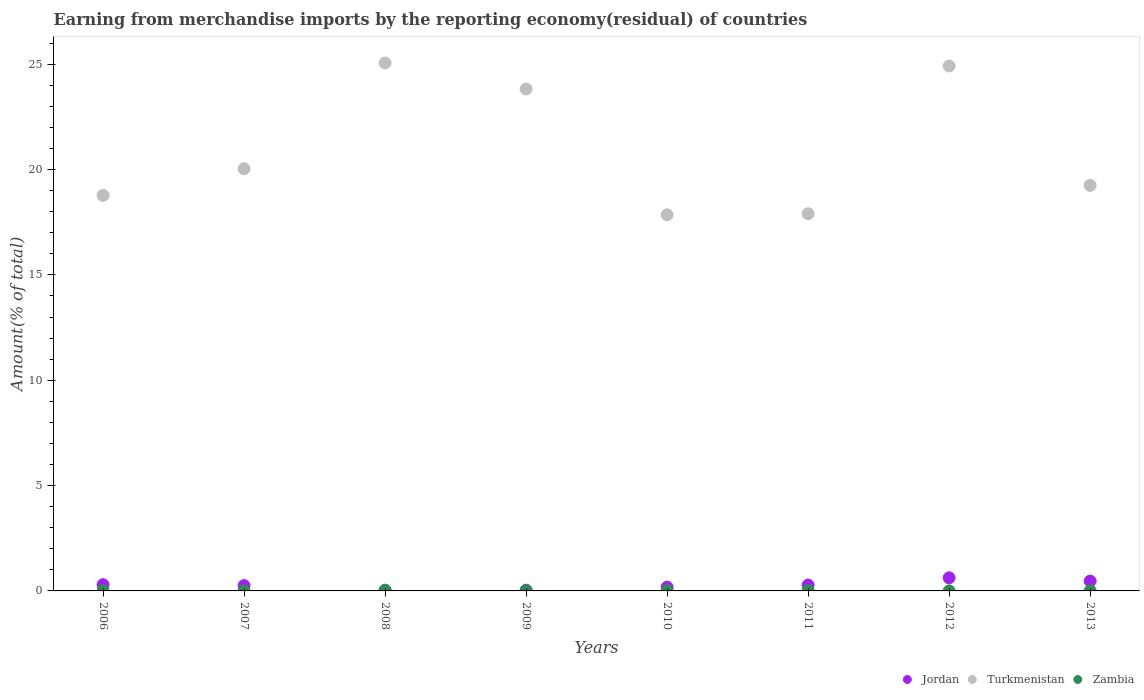How many different coloured dotlines are there?
Provide a succinct answer. 3. Is the number of dotlines equal to the number of legend labels?
Your response must be concise. Yes. What is the percentage of amount earned from merchandise imports in Turkmenistan in 2011?
Your answer should be compact. 17.9. Across all years, what is the maximum percentage of amount earned from merchandise imports in Zambia?
Your response must be concise. 0.03. Across all years, what is the minimum percentage of amount earned from merchandise imports in Jordan?
Your response must be concise. 0.03. In which year was the percentage of amount earned from merchandise imports in Turkmenistan maximum?
Provide a succinct answer. 2008. In which year was the percentage of amount earned from merchandise imports in Jordan minimum?
Offer a terse response. 2008. What is the total percentage of amount earned from merchandise imports in Turkmenistan in the graph?
Keep it short and to the point. 167.63. What is the difference between the percentage of amount earned from merchandise imports in Zambia in 2006 and that in 2009?
Provide a short and direct response. 0.01. What is the difference between the percentage of amount earned from merchandise imports in Turkmenistan in 2010 and the percentage of amount earned from merchandise imports in Jordan in 2007?
Offer a terse response. 17.6. What is the average percentage of amount earned from merchandise imports in Zambia per year?
Keep it short and to the point. 0.01. In the year 2012, what is the difference between the percentage of amount earned from merchandise imports in Turkmenistan and percentage of amount earned from merchandise imports in Jordan?
Make the answer very short. 24.3. In how many years, is the percentage of amount earned from merchandise imports in Jordan greater than 9 %?
Offer a terse response. 0. What is the ratio of the percentage of amount earned from merchandise imports in Turkmenistan in 2007 to that in 2008?
Provide a short and direct response. 0.8. Is the percentage of amount earned from merchandise imports in Zambia in 2008 less than that in 2010?
Your answer should be very brief. No. What is the difference between the highest and the second highest percentage of amount earned from merchandise imports in Zambia?
Provide a short and direct response. 0.01. What is the difference between the highest and the lowest percentage of amount earned from merchandise imports in Zambia?
Provide a short and direct response. 0.03. Is the sum of the percentage of amount earned from merchandise imports in Zambia in 2009 and 2011 greater than the maximum percentage of amount earned from merchandise imports in Turkmenistan across all years?
Provide a short and direct response. No. Is it the case that in every year, the sum of the percentage of amount earned from merchandise imports in Jordan and percentage of amount earned from merchandise imports in Zambia  is greater than the percentage of amount earned from merchandise imports in Turkmenistan?
Offer a very short reply. No. Is the percentage of amount earned from merchandise imports in Turkmenistan strictly greater than the percentage of amount earned from merchandise imports in Jordan over the years?
Keep it short and to the point. Yes. Is the percentage of amount earned from merchandise imports in Jordan strictly less than the percentage of amount earned from merchandise imports in Zambia over the years?
Your answer should be very brief. No. How many years are there in the graph?
Your answer should be compact. 8. What is the difference between two consecutive major ticks on the Y-axis?
Make the answer very short. 5. Are the values on the major ticks of Y-axis written in scientific E-notation?
Your answer should be compact. No. Does the graph contain any zero values?
Give a very brief answer. No. Where does the legend appear in the graph?
Keep it short and to the point. Bottom right. How many legend labels are there?
Keep it short and to the point. 3. How are the legend labels stacked?
Your response must be concise. Horizontal. What is the title of the graph?
Provide a succinct answer. Earning from merchandise imports by the reporting economy(residual) of countries. Does "Poland" appear as one of the legend labels in the graph?
Your answer should be very brief. No. What is the label or title of the Y-axis?
Provide a succinct answer. Amount(% of total). What is the Amount(% of total) in Jordan in 2006?
Your answer should be very brief. 0.3. What is the Amount(% of total) of Turkmenistan in 2006?
Provide a succinct answer. 18.78. What is the Amount(% of total) in Zambia in 2006?
Your response must be concise. 0.01. What is the Amount(% of total) of Jordan in 2007?
Ensure brevity in your answer.  0.25. What is the Amount(% of total) in Turkmenistan in 2007?
Your answer should be compact. 20.04. What is the Amount(% of total) in Zambia in 2007?
Give a very brief answer. 0. What is the Amount(% of total) of Jordan in 2008?
Give a very brief answer. 0.03. What is the Amount(% of total) in Turkmenistan in 2008?
Offer a very short reply. 25.06. What is the Amount(% of total) in Zambia in 2008?
Make the answer very short. 0.03. What is the Amount(% of total) in Jordan in 2009?
Ensure brevity in your answer.  0.04. What is the Amount(% of total) in Turkmenistan in 2009?
Make the answer very short. 23.83. What is the Amount(% of total) of Zambia in 2009?
Offer a very short reply. 0.01. What is the Amount(% of total) in Jordan in 2010?
Your answer should be compact. 0.18. What is the Amount(% of total) of Turkmenistan in 2010?
Ensure brevity in your answer.  17.85. What is the Amount(% of total) of Zambia in 2010?
Make the answer very short. 0.01. What is the Amount(% of total) of Jordan in 2011?
Offer a terse response. 0.28. What is the Amount(% of total) in Turkmenistan in 2011?
Keep it short and to the point. 17.9. What is the Amount(% of total) of Zambia in 2011?
Ensure brevity in your answer.  0.02. What is the Amount(% of total) of Jordan in 2012?
Offer a terse response. 0.62. What is the Amount(% of total) in Turkmenistan in 2012?
Offer a very short reply. 24.92. What is the Amount(% of total) of Zambia in 2012?
Offer a very short reply. 0. What is the Amount(% of total) of Jordan in 2013?
Ensure brevity in your answer.  0.47. What is the Amount(% of total) of Turkmenistan in 2013?
Make the answer very short. 19.25. What is the Amount(% of total) in Zambia in 2013?
Provide a short and direct response. 0.01. Across all years, what is the maximum Amount(% of total) in Jordan?
Your response must be concise. 0.62. Across all years, what is the maximum Amount(% of total) of Turkmenistan?
Keep it short and to the point. 25.06. Across all years, what is the maximum Amount(% of total) of Zambia?
Keep it short and to the point. 0.03. Across all years, what is the minimum Amount(% of total) of Jordan?
Provide a succinct answer. 0.03. Across all years, what is the minimum Amount(% of total) in Turkmenistan?
Your answer should be very brief. 17.85. Across all years, what is the minimum Amount(% of total) in Zambia?
Offer a very short reply. 0. What is the total Amount(% of total) of Jordan in the graph?
Keep it short and to the point. 2.17. What is the total Amount(% of total) of Turkmenistan in the graph?
Give a very brief answer. 167.63. What is the total Amount(% of total) of Zambia in the graph?
Offer a very short reply. 0.1. What is the difference between the Amount(% of total) of Jordan in 2006 and that in 2007?
Provide a succinct answer. 0.04. What is the difference between the Amount(% of total) in Turkmenistan in 2006 and that in 2007?
Your answer should be compact. -1.26. What is the difference between the Amount(% of total) of Zambia in 2006 and that in 2007?
Keep it short and to the point. 0.01. What is the difference between the Amount(% of total) of Jordan in 2006 and that in 2008?
Offer a terse response. 0.26. What is the difference between the Amount(% of total) in Turkmenistan in 2006 and that in 2008?
Your answer should be very brief. -6.28. What is the difference between the Amount(% of total) of Zambia in 2006 and that in 2008?
Give a very brief answer. -0.02. What is the difference between the Amount(% of total) of Jordan in 2006 and that in 2009?
Keep it short and to the point. 0.26. What is the difference between the Amount(% of total) of Turkmenistan in 2006 and that in 2009?
Give a very brief answer. -5.05. What is the difference between the Amount(% of total) in Zambia in 2006 and that in 2009?
Offer a very short reply. 0.01. What is the difference between the Amount(% of total) of Jordan in 2006 and that in 2010?
Offer a terse response. 0.12. What is the difference between the Amount(% of total) of Turkmenistan in 2006 and that in 2010?
Provide a short and direct response. 0.92. What is the difference between the Amount(% of total) in Zambia in 2006 and that in 2010?
Keep it short and to the point. 0. What is the difference between the Amount(% of total) in Jordan in 2006 and that in 2011?
Your answer should be compact. 0.01. What is the difference between the Amount(% of total) of Turkmenistan in 2006 and that in 2011?
Give a very brief answer. 0.87. What is the difference between the Amount(% of total) in Zambia in 2006 and that in 2011?
Your answer should be compact. -0.01. What is the difference between the Amount(% of total) in Jordan in 2006 and that in 2012?
Offer a very short reply. -0.33. What is the difference between the Amount(% of total) in Turkmenistan in 2006 and that in 2012?
Keep it short and to the point. -6.14. What is the difference between the Amount(% of total) of Zambia in 2006 and that in 2012?
Your answer should be compact. 0.01. What is the difference between the Amount(% of total) in Jordan in 2006 and that in 2013?
Keep it short and to the point. -0.17. What is the difference between the Amount(% of total) of Turkmenistan in 2006 and that in 2013?
Make the answer very short. -0.47. What is the difference between the Amount(% of total) in Zambia in 2006 and that in 2013?
Your answer should be very brief. 0. What is the difference between the Amount(% of total) in Jordan in 2007 and that in 2008?
Make the answer very short. 0.22. What is the difference between the Amount(% of total) in Turkmenistan in 2007 and that in 2008?
Your response must be concise. -5.02. What is the difference between the Amount(% of total) in Zambia in 2007 and that in 2008?
Keep it short and to the point. -0.02. What is the difference between the Amount(% of total) in Jordan in 2007 and that in 2009?
Your response must be concise. 0.22. What is the difference between the Amount(% of total) of Turkmenistan in 2007 and that in 2009?
Keep it short and to the point. -3.79. What is the difference between the Amount(% of total) in Zambia in 2007 and that in 2009?
Offer a very short reply. -0. What is the difference between the Amount(% of total) in Jordan in 2007 and that in 2010?
Make the answer very short. 0.07. What is the difference between the Amount(% of total) in Turkmenistan in 2007 and that in 2010?
Your answer should be very brief. 2.19. What is the difference between the Amount(% of total) of Zambia in 2007 and that in 2010?
Offer a terse response. -0.01. What is the difference between the Amount(% of total) of Jordan in 2007 and that in 2011?
Provide a succinct answer. -0.03. What is the difference between the Amount(% of total) in Turkmenistan in 2007 and that in 2011?
Keep it short and to the point. 2.14. What is the difference between the Amount(% of total) in Zambia in 2007 and that in 2011?
Your answer should be compact. -0.02. What is the difference between the Amount(% of total) of Jordan in 2007 and that in 2012?
Your answer should be compact. -0.37. What is the difference between the Amount(% of total) in Turkmenistan in 2007 and that in 2012?
Your answer should be compact. -4.88. What is the difference between the Amount(% of total) in Zambia in 2007 and that in 2012?
Provide a short and direct response. 0. What is the difference between the Amount(% of total) in Jordan in 2007 and that in 2013?
Your response must be concise. -0.22. What is the difference between the Amount(% of total) of Turkmenistan in 2007 and that in 2013?
Give a very brief answer. 0.79. What is the difference between the Amount(% of total) of Zambia in 2007 and that in 2013?
Offer a terse response. -0.01. What is the difference between the Amount(% of total) in Jordan in 2008 and that in 2009?
Provide a succinct answer. -0. What is the difference between the Amount(% of total) of Turkmenistan in 2008 and that in 2009?
Provide a succinct answer. 1.23. What is the difference between the Amount(% of total) of Zambia in 2008 and that in 2009?
Your answer should be compact. 0.02. What is the difference between the Amount(% of total) of Jordan in 2008 and that in 2010?
Provide a succinct answer. -0.15. What is the difference between the Amount(% of total) of Turkmenistan in 2008 and that in 2010?
Provide a short and direct response. 7.21. What is the difference between the Amount(% of total) of Zambia in 2008 and that in 2010?
Keep it short and to the point. 0.02. What is the difference between the Amount(% of total) of Jordan in 2008 and that in 2011?
Your response must be concise. -0.25. What is the difference between the Amount(% of total) of Turkmenistan in 2008 and that in 2011?
Your answer should be very brief. 7.16. What is the difference between the Amount(% of total) of Zambia in 2008 and that in 2011?
Your response must be concise. 0.01. What is the difference between the Amount(% of total) of Jordan in 2008 and that in 2012?
Your response must be concise. -0.59. What is the difference between the Amount(% of total) of Turkmenistan in 2008 and that in 2012?
Provide a succinct answer. 0.14. What is the difference between the Amount(% of total) of Zambia in 2008 and that in 2012?
Provide a succinct answer. 0.03. What is the difference between the Amount(% of total) of Jordan in 2008 and that in 2013?
Offer a very short reply. -0.44. What is the difference between the Amount(% of total) in Turkmenistan in 2008 and that in 2013?
Your response must be concise. 5.81. What is the difference between the Amount(% of total) in Zambia in 2008 and that in 2013?
Make the answer very short. 0.02. What is the difference between the Amount(% of total) of Jordan in 2009 and that in 2010?
Give a very brief answer. -0.15. What is the difference between the Amount(% of total) in Turkmenistan in 2009 and that in 2010?
Make the answer very short. 5.97. What is the difference between the Amount(% of total) of Zambia in 2009 and that in 2010?
Give a very brief answer. -0. What is the difference between the Amount(% of total) in Jordan in 2009 and that in 2011?
Ensure brevity in your answer.  -0.25. What is the difference between the Amount(% of total) in Turkmenistan in 2009 and that in 2011?
Provide a succinct answer. 5.92. What is the difference between the Amount(% of total) in Zambia in 2009 and that in 2011?
Offer a terse response. -0.02. What is the difference between the Amount(% of total) in Jordan in 2009 and that in 2012?
Ensure brevity in your answer.  -0.59. What is the difference between the Amount(% of total) of Turkmenistan in 2009 and that in 2012?
Keep it short and to the point. -1.09. What is the difference between the Amount(% of total) in Zambia in 2009 and that in 2012?
Offer a very short reply. 0. What is the difference between the Amount(% of total) of Jordan in 2009 and that in 2013?
Offer a terse response. -0.43. What is the difference between the Amount(% of total) in Turkmenistan in 2009 and that in 2013?
Provide a short and direct response. 4.58. What is the difference between the Amount(% of total) in Zambia in 2009 and that in 2013?
Provide a succinct answer. -0. What is the difference between the Amount(% of total) of Jordan in 2010 and that in 2011?
Provide a succinct answer. -0.1. What is the difference between the Amount(% of total) in Turkmenistan in 2010 and that in 2011?
Your response must be concise. -0.05. What is the difference between the Amount(% of total) of Zambia in 2010 and that in 2011?
Give a very brief answer. -0.01. What is the difference between the Amount(% of total) of Jordan in 2010 and that in 2012?
Your answer should be compact. -0.44. What is the difference between the Amount(% of total) in Turkmenistan in 2010 and that in 2012?
Give a very brief answer. -7.07. What is the difference between the Amount(% of total) of Zambia in 2010 and that in 2012?
Offer a terse response. 0.01. What is the difference between the Amount(% of total) of Jordan in 2010 and that in 2013?
Give a very brief answer. -0.29. What is the difference between the Amount(% of total) in Turkmenistan in 2010 and that in 2013?
Provide a succinct answer. -1.4. What is the difference between the Amount(% of total) of Zambia in 2010 and that in 2013?
Offer a very short reply. -0. What is the difference between the Amount(% of total) of Jordan in 2011 and that in 2012?
Ensure brevity in your answer.  -0.34. What is the difference between the Amount(% of total) in Turkmenistan in 2011 and that in 2012?
Keep it short and to the point. -7.02. What is the difference between the Amount(% of total) of Zambia in 2011 and that in 2012?
Give a very brief answer. 0.02. What is the difference between the Amount(% of total) of Jordan in 2011 and that in 2013?
Provide a succinct answer. -0.19. What is the difference between the Amount(% of total) of Turkmenistan in 2011 and that in 2013?
Offer a terse response. -1.35. What is the difference between the Amount(% of total) of Zambia in 2011 and that in 2013?
Offer a very short reply. 0.01. What is the difference between the Amount(% of total) in Jordan in 2012 and that in 2013?
Give a very brief answer. 0.15. What is the difference between the Amount(% of total) in Turkmenistan in 2012 and that in 2013?
Keep it short and to the point. 5.67. What is the difference between the Amount(% of total) in Zambia in 2012 and that in 2013?
Provide a succinct answer. -0.01. What is the difference between the Amount(% of total) in Jordan in 2006 and the Amount(% of total) in Turkmenistan in 2007?
Provide a short and direct response. -19.74. What is the difference between the Amount(% of total) of Jordan in 2006 and the Amount(% of total) of Zambia in 2007?
Make the answer very short. 0.29. What is the difference between the Amount(% of total) of Turkmenistan in 2006 and the Amount(% of total) of Zambia in 2007?
Offer a very short reply. 18.77. What is the difference between the Amount(% of total) in Jordan in 2006 and the Amount(% of total) in Turkmenistan in 2008?
Give a very brief answer. -24.76. What is the difference between the Amount(% of total) of Jordan in 2006 and the Amount(% of total) of Zambia in 2008?
Keep it short and to the point. 0.27. What is the difference between the Amount(% of total) of Turkmenistan in 2006 and the Amount(% of total) of Zambia in 2008?
Offer a very short reply. 18.75. What is the difference between the Amount(% of total) of Jordan in 2006 and the Amount(% of total) of Turkmenistan in 2009?
Offer a terse response. -23.53. What is the difference between the Amount(% of total) of Jordan in 2006 and the Amount(% of total) of Zambia in 2009?
Provide a succinct answer. 0.29. What is the difference between the Amount(% of total) of Turkmenistan in 2006 and the Amount(% of total) of Zambia in 2009?
Offer a very short reply. 18.77. What is the difference between the Amount(% of total) of Jordan in 2006 and the Amount(% of total) of Turkmenistan in 2010?
Your answer should be compact. -17.56. What is the difference between the Amount(% of total) in Jordan in 2006 and the Amount(% of total) in Zambia in 2010?
Ensure brevity in your answer.  0.29. What is the difference between the Amount(% of total) in Turkmenistan in 2006 and the Amount(% of total) in Zambia in 2010?
Offer a very short reply. 18.77. What is the difference between the Amount(% of total) in Jordan in 2006 and the Amount(% of total) in Turkmenistan in 2011?
Offer a very short reply. -17.61. What is the difference between the Amount(% of total) of Jordan in 2006 and the Amount(% of total) of Zambia in 2011?
Give a very brief answer. 0.27. What is the difference between the Amount(% of total) of Turkmenistan in 2006 and the Amount(% of total) of Zambia in 2011?
Keep it short and to the point. 18.75. What is the difference between the Amount(% of total) in Jordan in 2006 and the Amount(% of total) in Turkmenistan in 2012?
Ensure brevity in your answer.  -24.62. What is the difference between the Amount(% of total) of Jordan in 2006 and the Amount(% of total) of Zambia in 2012?
Keep it short and to the point. 0.29. What is the difference between the Amount(% of total) in Turkmenistan in 2006 and the Amount(% of total) in Zambia in 2012?
Your answer should be very brief. 18.77. What is the difference between the Amount(% of total) of Jordan in 2006 and the Amount(% of total) of Turkmenistan in 2013?
Provide a short and direct response. -18.95. What is the difference between the Amount(% of total) of Jordan in 2006 and the Amount(% of total) of Zambia in 2013?
Offer a terse response. 0.28. What is the difference between the Amount(% of total) of Turkmenistan in 2006 and the Amount(% of total) of Zambia in 2013?
Your answer should be compact. 18.77. What is the difference between the Amount(% of total) in Jordan in 2007 and the Amount(% of total) in Turkmenistan in 2008?
Make the answer very short. -24.81. What is the difference between the Amount(% of total) in Jordan in 2007 and the Amount(% of total) in Zambia in 2008?
Provide a short and direct response. 0.22. What is the difference between the Amount(% of total) in Turkmenistan in 2007 and the Amount(% of total) in Zambia in 2008?
Offer a very short reply. 20.01. What is the difference between the Amount(% of total) of Jordan in 2007 and the Amount(% of total) of Turkmenistan in 2009?
Make the answer very short. -23.58. What is the difference between the Amount(% of total) in Jordan in 2007 and the Amount(% of total) in Zambia in 2009?
Keep it short and to the point. 0.24. What is the difference between the Amount(% of total) in Turkmenistan in 2007 and the Amount(% of total) in Zambia in 2009?
Your answer should be very brief. 20.03. What is the difference between the Amount(% of total) in Jordan in 2007 and the Amount(% of total) in Turkmenistan in 2010?
Offer a terse response. -17.6. What is the difference between the Amount(% of total) in Jordan in 2007 and the Amount(% of total) in Zambia in 2010?
Provide a succinct answer. 0.24. What is the difference between the Amount(% of total) in Turkmenistan in 2007 and the Amount(% of total) in Zambia in 2010?
Provide a succinct answer. 20.03. What is the difference between the Amount(% of total) in Jordan in 2007 and the Amount(% of total) in Turkmenistan in 2011?
Make the answer very short. -17.65. What is the difference between the Amount(% of total) of Jordan in 2007 and the Amount(% of total) of Zambia in 2011?
Keep it short and to the point. 0.23. What is the difference between the Amount(% of total) of Turkmenistan in 2007 and the Amount(% of total) of Zambia in 2011?
Your response must be concise. 20.02. What is the difference between the Amount(% of total) of Jordan in 2007 and the Amount(% of total) of Turkmenistan in 2012?
Provide a short and direct response. -24.67. What is the difference between the Amount(% of total) in Jordan in 2007 and the Amount(% of total) in Zambia in 2012?
Your answer should be compact. 0.25. What is the difference between the Amount(% of total) of Turkmenistan in 2007 and the Amount(% of total) of Zambia in 2012?
Make the answer very short. 20.04. What is the difference between the Amount(% of total) of Jordan in 2007 and the Amount(% of total) of Turkmenistan in 2013?
Your answer should be compact. -19. What is the difference between the Amount(% of total) of Jordan in 2007 and the Amount(% of total) of Zambia in 2013?
Ensure brevity in your answer.  0.24. What is the difference between the Amount(% of total) in Turkmenistan in 2007 and the Amount(% of total) in Zambia in 2013?
Keep it short and to the point. 20.03. What is the difference between the Amount(% of total) in Jordan in 2008 and the Amount(% of total) in Turkmenistan in 2009?
Your answer should be very brief. -23.8. What is the difference between the Amount(% of total) of Jordan in 2008 and the Amount(% of total) of Zambia in 2009?
Make the answer very short. 0.02. What is the difference between the Amount(% of total) of Turkmenistan in 2008 and the Amount(% of total) of Zambia in 2009?
Provide a succinct answer. 25.05. What is the difference between the Amount(% of total) in Jordan in 2008 and the Amount(% of total) in Turkmenistan in 2010?
Your response must be concise. -17.82. What is the difference between the Amount(% of total) in Jordan in 2008 and the Amount(% of total) in Zambia in 2010?
Ensure brevity in your answer.  0.02. What is the difference between the Amount(% of total) in Turkmenistan in 2008 and the Amount(% of total) in Zambia in 2010?
Provide a succinct answer. 25.05. What is the difference between the Amount(% of total) of Jordan in 2008 and the Amount(% of total) of Turkmenistan in 2011?
Provide a succinct answer. -17.87. What is the difference between the Amount(% of total) of Jordan in 2008 and the Amount(% of total) of Zambia in 2011?
Your response must be concise. 0.01. What is the difference between the Amount(% of total) of Turkmenistan in 2008 and the Amount(% of total) of Zambia in 2011?
Your answer should be compact. 25.04. What is the difference between the Amount(% of total) of Jordan in 2008 and the Amount(% of total) of Turkmenistan in 2012?
Make the answer very short. -24.89. What is the difference between the Amount(% of total) in Jordan in 2008 and the Amount(% of total) in Zambia in 2012?
Ensure brevity in your answer.  0.03. What is the difference between the Amount(% of total) of Turkmenistan in 2008 and the Amount(% of total) of Zambia in 2012?
Provide a short and direct response. 25.06. What is the difference between the Amount(% of total) of Jordan in 2008 and the Amount(% of total) of Turkmenistan in 2013?
Provide a succinct answer. -19.22. What is the difference between the Amount(% of total) in Jordan in 2008 and the Amount(% of total) in Zambia in 2013?
Provide a succinct answer. 0.02. What is the difference between the Amount(% of total) of Turkmenistan in 2008 and the Amount(% of total) of Zambia in 2013?
Give a very brief answer. 25.05. What is the difference between the Amount(% of total) in Jordan in 2009 and the Amount(% of total) in Turkmenistan in 2010?
Ensure brevity in your answer.  -17.82. What is the difference between the Amount(% of total) of Jordan in 2009 and the Amount(% of total) of Zambia in 2010?
Keep it short and to the point. 0.03. What is the difference between the Amount(% of total) of Turkmenistan in 2009 and the Amount(% of total) of Zambia in 2010?
Make the answer very short. 23.82. What is the difference between the Amount(% of total) in Jordan in 2009 and the Amount(% of total) in Turkmenistan in 2011?
Provide a short and direct response. -17.87. What is the difference between the Amount(% of total) in Jordan in 2009 and the Amount(% of total) in Zambia in 2011?
Your response must be concise. 0.01. What is the difference between the Amount(% of total) of Turkmenistan in 2009 and the Amount(% of total) of Zambia in 2011?
Keep it short and to the point. 23.8. What is the difference between the Amount(% of total) of Jordan in 2009 and the Amount(% of total) of Turkmenistan in 2012?
Your answer should be very brief. -24.89. What is the difference between the Amount(% of total) of Jordan in 2009 and the Amount(% of total) of Zambia in 2012?
Ensure brevity in your answer.  0.03. What is the difference between the Amount(% of total) in Turkmenistan in 2009 and the Amount(% of total) in Zambia in 2012?
Ensure brevity in your answer.  23.82. What is the difference between the Amount(% of total) in Jordan in 2009 and the Amount(% of total) in Turkmenistan in 2013?
Ensure brevity in your answer.  -19.22. What is the difference between the Amount(% of total) of Jordan in 2009 and the Amount(% of total) of Zambia in 2013?
Ensure brevity in your answer.  0.02. What is the difference between the Amount(% of total) in Turkmenistan in 2009 and the Amount(% of total) in Zambia in 2013?
Keep it short and to the point. 23.82. What is the difference between the Amount(% of total) in Jordan in 2010 and the Amount(% of total) in Turkmenistan in 2011?
Make the answer very short. -17.72. What is the difference between the Amount(% of total) in Jordan in 2010 and the Amount(% of total) in Zambia in 2011?
Provide a short and direct response. 0.16. What is the difference between the Amount(% of total) in Turkmenistan in 2010 and the Amount(% of total) in Zambia in 2011?
Provide a short and direct response. 17.83. What is the difference between the Amount(% of total) in Jordan in 2010 and the Amount(% of total) in Turkmenistan in 2012?
Your answer should be compact. -24.74. What is the difference between the Amount(% of total) of Jordan in 2010 and the Amount(% of total) of Zambia in 2012?
Provide a succinct answer. 0.18. What is the difference between the Amount(% of total) in Turkmenistan in 2010 and the Amount(% of total) in Zambia in 2012?
Provide a short and direct response. 17.85. What is the difference between the Amount(% of total) in Jordan in 2010 and the Amount(% of total) in Turkmenistan in 2013?
Offer a terse response. -19.07. What is the difference between the Amount(% of total) of Jordan in 2010 and the Amount(% of total) of Zambia in 2013?
Offer a very short reply. 0.17. What is the difference between the Amount(% of total) in Turkmenistan in 2010 and the Amount(% of total) in Zambia in 2013?
Your answer should be very brief. 17.84. What is the difference between the Amount(% of total) of Jordan in 2011 and the Amount(% of total) of Turkmenistan in 2012?
Keep it short and to the point. -24.64. What is the difference between the Amount(% of total) in Jordan in 2011 and the Amount(% of total) in Zambia in 2012?
Your answer should be compact. 0.28. What is the difference between the Amount(% of total) of Turkmenistan in 2011 and the Amount(% of total) of Zambia in 2012?
Make the answer very short. 17.9. What is the difference between the Amount(% of total) of Jordan in 2011 and the Amount(% of total) of Turkmenistan in 2013?
Offer a very short reply. -18.97. What is the difference between the Amount(% of total) in Jordan in 2011 and the Amount(% of total) in Zambia in 2013?
Your answer should be very brief. 0.27. What is the difference between the Amount(% of total) of Turkmenistan in 2011 and the Amount(% of total) of Zambia in 2013?
Keep it short and to the point. 17.89. What is the difference between the Amount(% of total) of Jordan in 2012 and the Amount(% of total) of Turkmenistan in 2013?
Your response must be concise. -18.63. What is the difference between the Amount(% of total) of Jordan in 2012 and the Amount(% of total) of Zambia in 2013?
Provide a short and direct response. 0.61. What is the difference between the Amount(% of total) of Turkmenistan in 2012 and the Amount(% of total) of Zambia in 2013?
Offer a terse response. 24.91. What is the average Amount(% of total) in Jordan per year?
Provide a short and direct response. 0.27. What is the average Amount(% of total) in Turkmenistan per year?
Offer a very short reply. 20.95. What is the average Amount(% of total) of Zambia per year?
Your answer should be very brief. 0.01. In the year 2006, what is the difference between the Amount(% of total) of Jordan and Amount(% of total) of Turkmenistan?
Your answer should be very brief. -18.48. In the year 2006, what is the difference between the Amount(% of total) of Jordan and Amount(% of total) of Zambia?
Ensure brevity in your answer.  0.28. In the year 2006, what is the difference between the Amount(% of total) of Turkmenistan and Amount(% of total) of Zambia?
Make the answer very short. 18.76. In the year 2007, what is the difference between the Amount(% of total) of Jordan and Amount(% of total) of Turkmenistan?
Your response must be concise. -19.79. In the year 2007, what is the difference between the Amount(% of total) in Jordan and Amount(% of total) in Zambia?
Offer a very short reply. 0.25. In the year 2007, what is the difference between the Amount(% of total) of Turkmenistan and Amount(% of total) of Zambia?
Provide a succinct answer. 20.04. In the year 2008, what is the difference between the Amount(% of total) in Jordan and Amount(% of total) in Turkmenistan?
Provide a succinct answer. -25.03. In the year 2008, what is the difference between the Amount(% of total) in Jordan and Amount(% of total) in Zambia?
Give a very brief answer. 0. In the year 2008, what is the difference between the Amount(% of total) in Turkmenistan and Amount(% of total) in Zambia?
Provide a short and direct response. 25.03. In the year 2009, what is the difference between the Amount(% of total) of Jordan and Amount(% of total) of Turkmenistan?
Give a very brief answer. -23.79. In the year 2009, what is the difference between the Amount(% of total) of Jordan and Amount(% of total) of Zambia?
Your response must be concise. 0.03. In the year 2009, what is the difference between the Amount(% of total) in Turkmenistan and Amount(% of total) in Zambia?
Make the answer very short. 23.82. In the year 2010, what is the difference between the Amount(% of total) of Jordan and Amount(% of total) of Turkmenistan?
Your answer should be very brief. -17.67. In the year 2010, what is the difference between the Amount(% of total) in Jordan and Amount(% of total) in Zambia?
Offer a terse response. 0.17. In the year 2010, what is the difference between the Amount(% of total) in Turkmenistan and Amount(% of total) in Zambia?
Offer a very short reply. 17.84. In the year 2011, what is the difference between the Amount(% of total) in Jordan and Amount(% of total) in Turkmenistan?
Your answer should be compact. -17.62. In the year 2011, what is the difference between the Amount(% of total) of Jordan and Amount(% of total) of Zambia?
Give a very brief answer. 0.26. In the year 2011, what is the difference between the Amount(% of total) of Turkmenistan and Amount(% of total) of Zambia?
Your answer should be very brief. 17.88. In the year 2012, what is the difference between the Amount(% of total) in Jordan and Amount(% of total) in Turkmenistan?
Offer a terse response. -24.3. In the year 2012, what is the difference between the Amount(% of total) in Jordan and Amount(% of total) in Zambia?
Offer a terse response. 0.62. In the year 2012, what is the difference between the Amount(% of total) in Turkmenistan and Amount(% of total) in Zambia?
Ensure brevity in your answer.  24.92. In the year 2013, what is the difference between the Amount(% of total) of Jordan and Amount(% of total) of Turkmenistan?
Your response must be concise. -18.78. In the year 2013, what is the difference between the Amount(% of total) of Jordan and Amount(% of total) of Zambia?
Keep it short and to the point. 0.46. In the year 2013, what is the difference between the Amount(% of total) of Turkmenistan and Amount(% of total) of Zambia?
Offer a very short reply. 19.24. What is the ratio of the Amount(% of total) of Jordan in 2006 to that in 2007?
Your answer should be very brief. 1.18. What is the ratio of the Amount(% of total) in Turkmenistan in 2006 to that in 2007?
Provide a short and direct response. 0.94. What is the ratio of the Amount(% of total) in Zambia in 2006 to that in 2007?
Offer a terse response. 2.81. What is the ratio of the Amount(% of total) of Jordan in 2006 to that in 2008?
Provide a short and direct response. 9.4. What is the ratio of the Amount(% of total) in Turkmenistan in 2006 to that in 2008?
Your answer should be very brief. 0.75. What is the ratio of the Amount(% of total) in Zambia in 2006 to that in 2008?
Make the answer very short. 0.42. What is the ratio of the Amount(% of total) of Jordan in 2006 to that in 2009?
Make the answer very short. 8.46. What is the ratio of the Amount(% of total) in Turkmenistan in 2006 to that in 2009?
Give a very brief answer. 0.79. What is the ratio of the Amount(% of total) of Zambia in 2006 to that in 2009?
Ensure brevity in your answer.  1.77. What is the ratio of the Amount(% of total) in Jordan in 2006 to that in 2010?
Give a very brief answer. 1.64. What is the ratio of the Amount(% of total) in Turkmenistan in 2006 to that in 2010?
Your answer should be very brief. 1.05. What is the ratio of the Amount(% of total) of Zambia in 2006 to that in 2010?
Offer a very short reply. 1.32. What is the ratio of the Amount(% of total) in Jordan in 2006 to that in 2011?
Give a very brief answer. 1.05. What is the ratio of the Amount(% of total) in Turkmenistan in 2006 to that in 2011?
Your answer should be compact. 1.05. What is the ratio of the Amount(% of total) in Zambia in 2006 to that in 2011?
Ensure brevity in your answer.  0.54. What is the ratio of the Amount(% of total) in Jordan in 2006 to that in 2012?
Your answer should be very brief. 0.48. What is the ratio of the Amount(% of total) of Turkmenistan in 2006 to that in 2012?
Your answer should be compact. 0.75. What is the ratio of the Amount(% of total) of Zambia in 2006 to that in 2012?
Provide a short and direct response. 5.45. What is the ratio of the Amount(% of total) of Jordan in 2006 to that in 2013?
Ensure brevity in your answer.  0.63. What is the ratio of the Amount(% of total) in Turkmenistan in 2006 to that in 2013?
Ensure brevity in your answer.  0.98. What is the ratio of the Amount(% of total) in Zambia in 2006 to that in 2013?
Your answer should be compact. 1.08. What is the ratio of the Amount(% of total) of Jordan in 2007 to that in 2008?
Offer a very short reply. 7.99. What is the ratio of the Amount(% of total) of Turkmenistan in 2007 to that in 2008?
Offer a very short reply. 0.8. What is the ratio of the Amount(% of total) of Zambia in 2007 to that in 2008?
Offer a terse response. 0.15. What is the ratio of the Amount(% of total) of Jordan in 2007 to that in 2009?
Your answer should be very brief. 7.19. What is the ratio of the Amount(% of total) in Turkmenistan in 2007 to that in 2009?
Your answer should be very brief. 0.84. What is the ratio of the Amount(% of total) in Zambia in 2007 to that in 2009?
Provide a short and direct response. 0.63. What is the ratio of the Amount(% of total) in Jordan in 2007 to that in 2010?
Provide a short and direct response. 1.39. What is the ratio of the Amount(% of total) in Turkmenistan in 2007 to that in 2010?
Your answer should be compact. 1.12. What is the ratio of the Amount(% of total) in Zambia in 2007 to that in 2010?
Offer a very short reply. 0.47. What is the ratio of the Amount(% of total) of Jordan in 2007 to that in 2011?
Offer a terse response. 0.89. What is the ratio of the Amount(% of total) in Turkmenistan in 2007 to that in 2011?
Provide a short and direct response. 1.12. What is the ratio of the Amount(% of total) of Zambia in 2007 to that in 2011?
Provide a succinct answer. 0.19. What is the ratio of the Amount(% of total) in Jordan in 2007 to that in 2012?
Offer a terse response. 0.4. What is the ratio of the Amount(% of total) in Turkmenistan in 2007 to that in 2012?
Keep it short and to the point. 0.8. What is the ratio of the Amount(% of total) of Zambia in 2007 to that in 2012?
Provide a short and direct response. 1.94. What is the ratio of the Amount(% of total) of Jordan in 2007 to that in 2013?
Your answer should be compact. 0.54. What is the ratio of the Amount(% of total) of Turkmenistan in 2007 to that in 2013?
Your answer should be compact. 1.04. What is the ratio of the Amount(% of total) in Zambia in 2007 to that in 2013?
Offer a terse response. 0.39. What is the ratio of the Amount(% of total) in Turkmenistan in 2008 to that in 2009?
Ensure brevity in your answer.  1.05. What is the ratio of the Amount(% of total) of Zambia in 2008 to that in 2009?
Give a very brief answer. 4.18. What is the ratio of the Amount(% of total) of Jordan in 2008 to that in 2010?
Your response must be concise. 0.17. What is the ratio of the Amount(% of total) of Turkmenistan in 2008 to that in 2010?
Offer a terse response. 1.4. What is the ratio of the Amount(% of total) of Zambia in 2008 to that in 2010?
Keep it short and to the point. 3.12. What is the ratio of the Amount(% of total) of Jordan in 2008 to that in 2011?
Provide a short and direct response. 0.11. What is the ratio of the Amount(% of total) of Turkmenistan in 2008 to that in 2011?
Offer a very short reply. 1.4. What is the ratio of the Amount(% of total) in Zambia in 2008 to that in 2011?
Keep it short and to the point. 1.28. What is the ratio of the Amount(% of total) of Jordan in 2008 to that in 2012?
Your response must be concise. 0.05. What is the ratio of the Amount(% of total) of Turkmenistan in 2008 to that in 2012?
Offer a very short reply. 1.01. What is the ratio of the Amount(% of total) in Zambia in 2008 to that in 2012?
Your answer should be very brief. 12.9. What is the ratio of the Amount(% of total) of Jordan in 2008 to that in 2013?
Give a very brief answer. 0.07. What is the ratio of the Amount(% of total) of Turkmenistan in 2008 to that in 2013?
Ensure brevity in your answer.  1.3. What is the ratio of the Amount(% of total) in Zambia in 2008 to that in 2013?
Provide a short and direct response. 2.56. What is the ratio of the Amount(% of total) in Jordan in 2009 to that in 2010?
Your answer should be very brief. 0.19. What is the ratio of the Amount(% of total) of Turkmenistan in 2009 to that in 2010?
Provide a succinct answer. 1.33. What is the ratio of the Amount(% of total) in Zambia in 2009 to that in 2010?
Provide a succinct answer. 0.75. What is the ratio of the Amount(% of total) in Jordan in 2009 to that in 2011?
Your answer should be compact. 0.12. What is the ratio of the Amount(% of total) in Turkmenistan in 2009 to that in 2011?
Give a very brief answer. 1.33. What is the ratio of the Amount(% of total) of Zambia in 2009 to that in 2011?
Make the answer very short. 0.31. What is the ratio of the Amount(% of total) in Jordan in 2009 to that in 2012?
Your response must be concise. 0.06. What is the ratio of the Amount(% of total) in Turkmenistan in 2009 to that in 2012?
Keep it short and to the point. 0.96. What is the ratio of the Amount(% of total) in Zambia in 2009 to that in 2012?
Give a very brief answer. 3.08. What is the ratio of the Amount(% of total) in Jordan in 2009 to that in 2013?
Provide a short and direct response. 0.07. What is the ratio of the Amount(% of total) in Turkmenistan in 2009 to that in 2013?
Offer a very short reply. 1.24. What is the ratio of the Amount(% of total) in Zambia in 2009 to that in 2013?
Keep it short and to the point. 0.61. What is the ratio of the Amount(% of total) of Jordan in 2010 to that in 2011?
Ensure brevity in your answer.  0.64. What is the ratio of the Amount(% of total) in Zambia in 2010 to that in 2011?
Your answer should be very brief. 0.41. What is the ratio of the Amount(% of total) of Jordan in 2010 to that in 2012?
Offer a terse response. 0.29. What is the ratio of the Amount(% of total) in Turkmenistan in 2010 to that in 2012?
Ensure brevity in your answer.  0.72. What is the ratio of the Amount(% of total) in Zambia in 2010 to that in 2012?
Ensure brevity in your answer.  4.13. What is the ratio of the Amount(% of total) of Jordan in 2010 to that in 2013?
Provide a short and direct response. 0.39. What is the ratio of the Amount(% of total) in Turkmenistan in 2010 to that in 2013?
Offer a terse response. 0.93. What is the ratio of the Amount(% of total) in Zambia in 2010 to that in 2013?
Your answer should be very brief. 0.82. What is the ratio of the Amount(% of total) of Jordan in 2011 to that in 2012?
Give a very brief answer. 0.45. What is the ratio of the Amount(% of total) in Turkmenistan in 2011 to that in 2012?
Provide a short and direct response. 0.72. What is the ratio of the Amount(% of total) of Zambia in 2011 to that in 2012?
Give a very brief answer. 10.09. What is the ratio of the Amount(% of total) of Jordan in 2011 to that in 2013?
Your response must be concise. 0.6. What is the ratio of the Amount(% of total) of Turkmenistan in 2011 to that in 2013?
Provide a succinct answer. 0.93. What is the ratio of the Amount(% of total) in Zambia in 2011 to that in 2013?
Keep it short and to the point. 2. What is the ratio of the Amount(% of total) in Jordan in 2012 to that in 2013?
Your answer should be compact. 1.33. What is the ratio of the Amount(% of total) in Turkmenistan in 2012 to that in 2013?
Provide a succinct answer. 1.29. What is the ratio of the Amount(% of total) of Zambia in 2012 to that in 2013?
Provide a succinct answer. 0.2. What is the difference between the highest and the second highest Amount(% of total) in Jordan?
Your response must be concise. 0.15. What is the difference between the highest and the second highest Amount(% of total) in Turkmenistan?
Offer a terse response. 0.14. What is the difference between the highest and the second highest Amount(% of total) in Zambia?
Offer a very short reply. 0.01. What is the difference between the highest and the lowest Amount(% of total) of Jordan?
Make the answer very short. 0.59. What is the difference between the highest and the lowest Amount(% of total) in Turkmenistan?
Your answer should be compact. 7.21. What is the difference between the highest and the lowest Amount(% of total) of Zambia?
Make the answer very short. 0.03. 